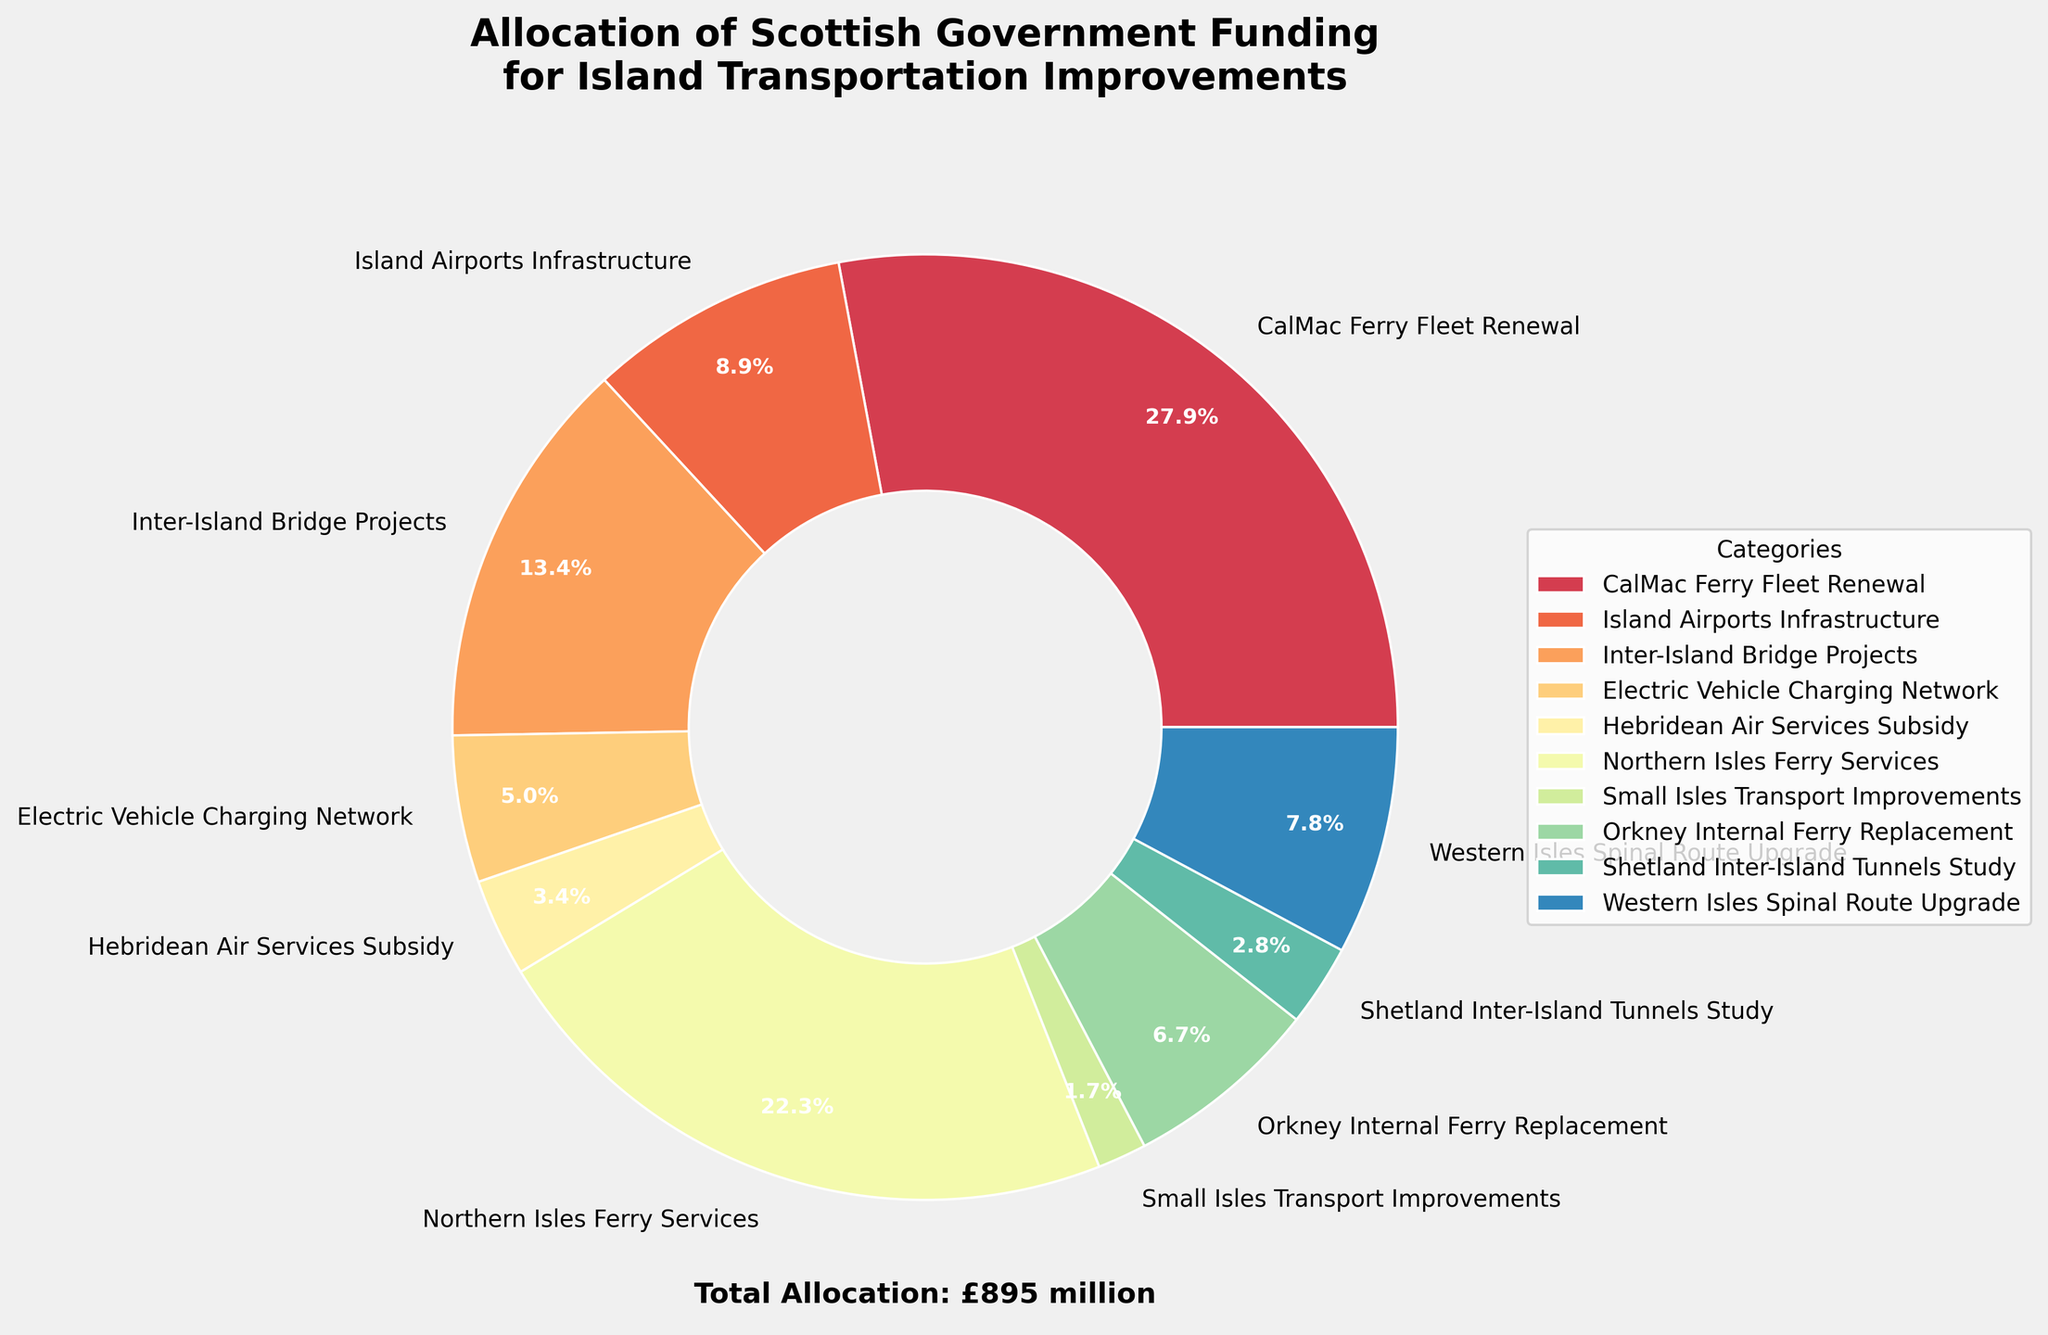What percentage of the total allocation is assigned to CalMac Ferry Fleet Renewal? We observe CalMac Ferry Fleet Renewal's label on the pie chart, which indicates its percentage share of the total allocation.
Answer: 31.3% Which category received the smallest allocation, and what is its percentage? By examining the pie chart labels, the smallest wedge is identified for Small Isles Transport Improvements, along with its corresponding percentage.
Answer: Small Isles Transport Improvements, 1.9% How does the allocation for Northern Isles Ferry Services compare with the allocation for Island Airports Infrastructure? From the pie chart, inspect both the Northern Isles Ferry Services and Island Airports Infrastructure wedges for proportional differences; Northern Isles Ferry Services is larger.
Answer: Northern Isles Ferry Services is larger What is the combined allocation for Inter-Island Bridge Projects and Western Isles Spinal Route Upgrade? To find the combined allocation, sum the amounts for Inter-Island Bridge Projects (£120 million) and Western Isles Spinal Route Upgrade (£70 million) from the pie chart.
Answer: £190 million Which category received a greater portion of the funding, Electric Vehicle Charging Network or Orkney Internal Ferry Replacement? Compare the sizes of the wedges representing Electric Vehicle Charging Network and Orkney Internal Ferry Replacement on the pie chart; the Orkney Internal Ferry Replacement wedge is larger.
Answer: Orkney Internal Ferry Replacement What's the total allocation for categories related to air services (Island Airports Infrastructure and Hebridean Air Services Subsidy)? Sum the allocations for Island Airports Infrastructure (£80 million) and Hebridean Air Services Subsidy (£30 million) as indicated on the pie chart.
Answer: £110 million How much more funding did CalMac Ferry Fleet Renewal receive compared to Shetland Inter-Island Tunnels Study? Subtract the allocation for Shetland Inter-Island Tunnels Study (£25 million) from that for CalMac Ferry Fleet Renewal (£250 million) according to the chart.
Answer: £225 million What is the color used for Northern Isles Ferry Services in the pie chart? Identify the segment labelled Northern Isles Ferry Services and note its color.
Answer: Specific color used in the pie chart (e.g., light blue, dark green, etc.) 